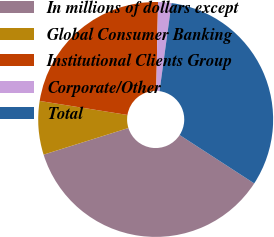<chart> <loc_0><loc_0><loc_500><loc_500><pie_chart><fcel>In millions of dollars except<fcel>Global Consumer Banking<fcel>Institutional Clients Group<fcel>Corporate/Other<fcel>Total<nl><fcel>36.0%<fcel>7.36%<fcel>22.8%<fcel>1.84%<fcel>32.0%<nl></chart> 